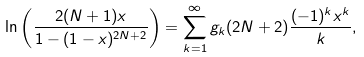<formula> <loc_0><loc_0><loc_500><loc_500>\ln \left ( \frac { 2 ( N + 1 ) x } { 1 - ( 1 - x ) ^ { 2 N + 2 } } \right ) = \sum _ { k = 1 } ^ { \infty } g _ { k } ( 2 N + 2 ) \frac { ( - 1 ) ^ { k } x ^ { k } } { k } ,</formula> 